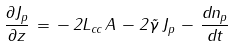<formula> <loc_0><loc_0><loc_500><loc_500>\frac { \partial J _ { p } } { \partial z } \, = \, - \, 2 L _ { c c } \, A \, - 2 \tilde { \gamma } \, J _ { p } \, - \, \frac { d n _ { p } } { d t }</formula> 